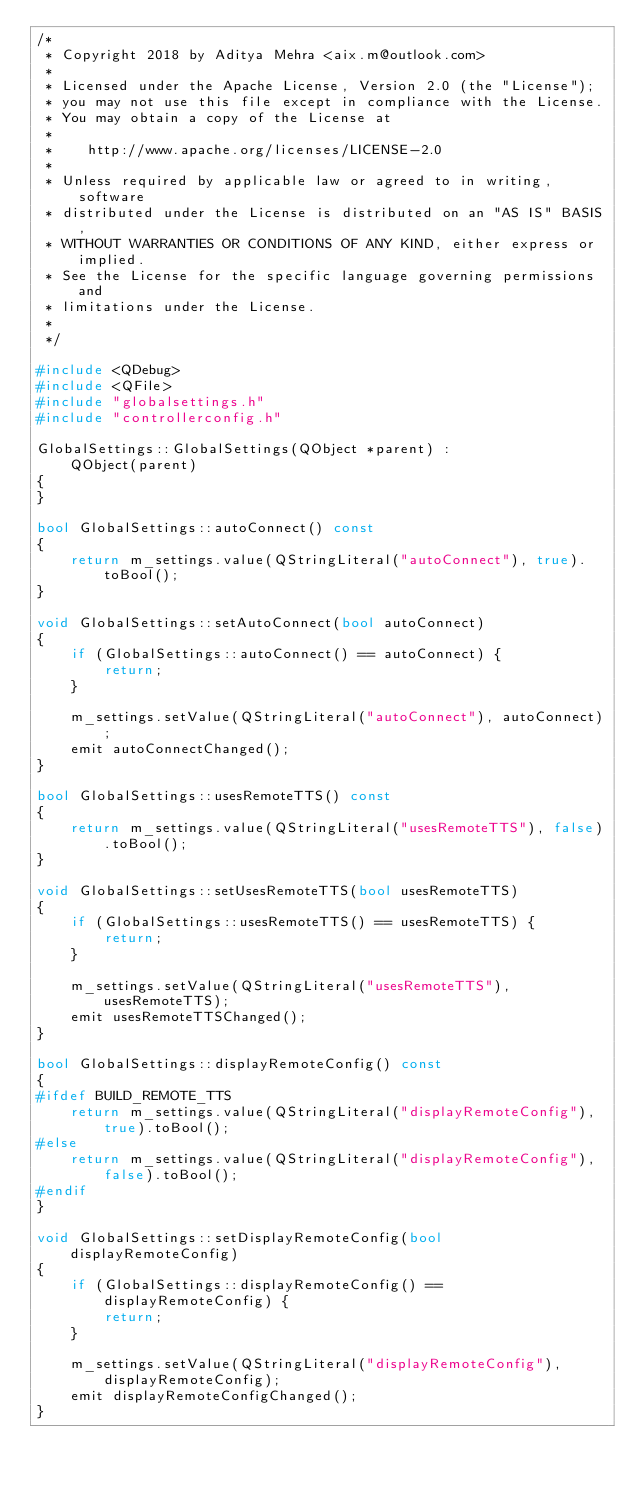<code> <loc_0><loc_0><loc_500><loc_500><_C++_>/*
 * Copyright 2018 by Aditya Mehra <aix.m@outlook.com>
 *
 * Licensed under the Apache License, Version 2.0 (the "License");
 * you may not use this file except in compliance with the License.
 * You may obtain a copy of the License at
 *
 *    http://www.apache.org/licenses/LICENSE-2.0
 *
 * Unless required by applicable law or agreed to in writing, software
 * distributed under the License is distributed on an "AS IS" BASIS,
 * WITHOUT WARRANTIES OR CONDITIONS OF ANY KIND, either express or implied.
 * See the License for the specific language governing permissions and
 * limitations under the License.
 *
 */

#include <QDebug>
#include <QFile>
#include "globalsettings.h"
#include "controllerconfig.h"

GlobalSettings::GlobalSettings(QObject *parent) :
    QObject(parent)
{
}

bool GlobalSettings::autoConnect() const
{
    return m_settings.value(QStringLiteral("autoConnect"), true).toBool();
}

void GlobalSettings::setAutoConnect(bool autoConnect)
{
    if (GlobalSettings::autoConnect() == autoConnect) {
        return;
    }

    m_settings.setValue(QStringLiteral("autoConnect"), autoConnect);
    emit autoConnectChanged();
}

bool GlobalSettings::usesRemoteTTS() const
{
    return m_settings.value(QStringLiteral("usesRemoteTTS"), false).toBool();
}

void GlobalSettings::setUsesRemoteTTS(bool usesRemoteTTS)
{
    if (GlobalSettings::usesRemoteTTS() == usesRemoteTTS) {
        return;
    }

    m_settings.setValue(QStringLiteral("usesRemoteTTS"), usesRemoteTTS);
    emit usesRemoteTTSChanged();
}

bool GlobalSettings::displayRemoteConfig() const
{
#ifdef BUILD_REMOTE_TTS
    return m_settings.value(QStringLiteral("displayRemoteConfig"), true).toBool();
#else
    return m_settings.value(QStringLiteral("displayRemoteConfig"), false).toBool();
#endif
}

void GlobalSettings::setDisplayRemoteConfig(bool displayRemoteConfig)
{
    if (GlobalSettings::displayRemoteConfig() == displayRemoteConfig) {
        return;
    }

    m_settings.setValue(QStringLiteral("displayRemoteConfig"), displayRemoteConfig);
    emit displayRemoteConfigChanged();
}
</code> 